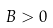Convert formula to latex. <formula><loc_0><loc_0><loc_500><loc_500>B > 0</formula> 